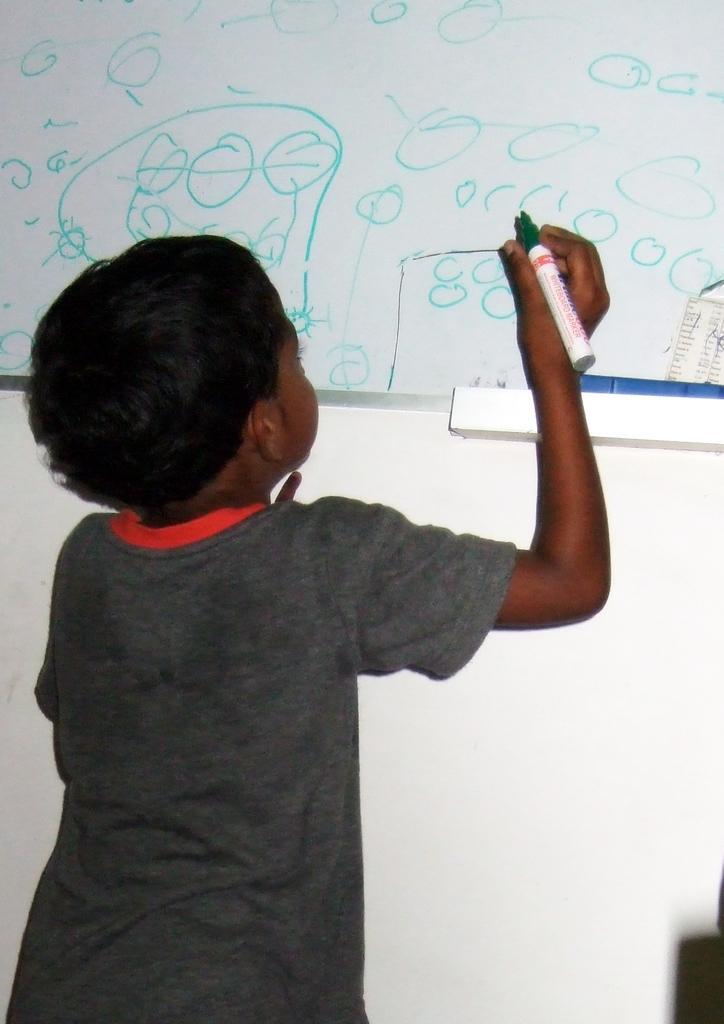How would you summarize this image in a sentence or two? In the picture I can see a boy is standing and holding a marker in the hand. I can also see a white color board on which something written on it. 